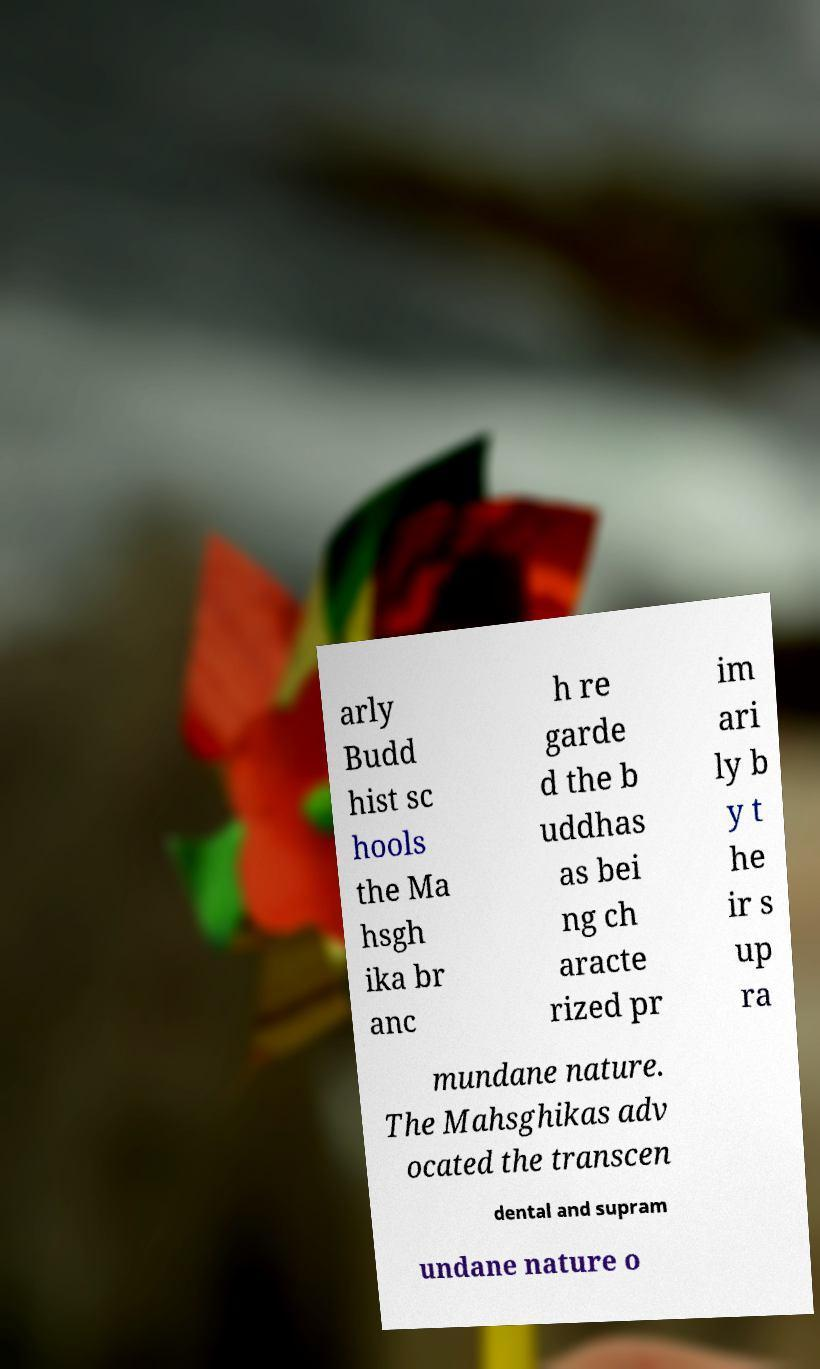Can you read and provide the text displayed in the image?This photo seems to have some interesting text. Can you extract and type it out for me? arly Budd hist sc hools the Ma hsgh ika br anc h re garde d the b uddhas as bei ng ch aracte rized pr im ari ly b y t he ir s up ra mundane nature. The Mahsghikas adv ocated the transcen dental and supram undane nature o 